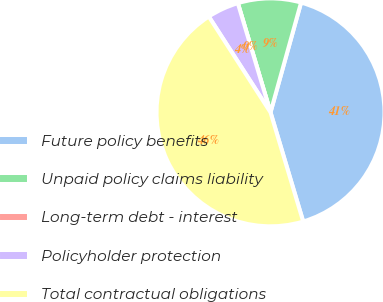Convert chart. <chart><loc_0><loc_0><loc_500><loc_500><pie_chart><fcel>Future policy benefits<fcel>Unpaid policy claims liability<fcel>Long-term debt - interest<fcel>Policyholder protection<fcel>Total contractual obligations<nl><fcel>41.05%<fcel>8.95%<fcel>0.0%<fcel>4.48%<fcel>45.52%<nl></chart> 